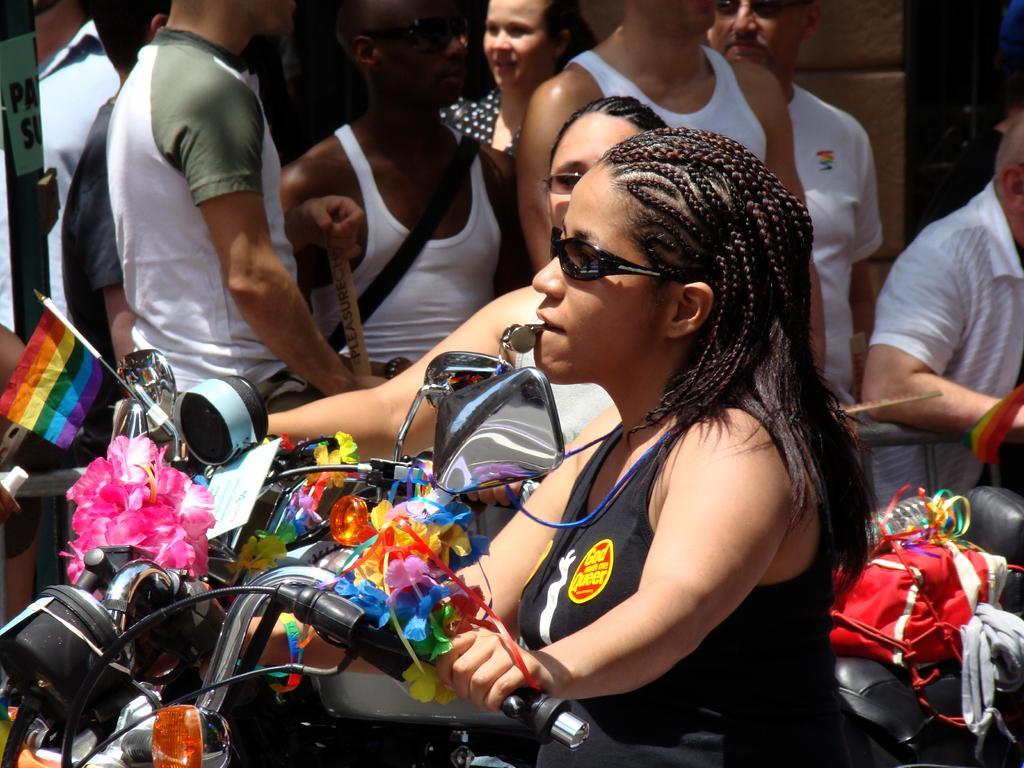How would you summarize this image in a sentence or two? In the foreground of the image we can see two women wearing goggles are riding motorcycles with some flowers, ribbons, flag bottle and a bag. In the background, we can see group of people standing and a building. 